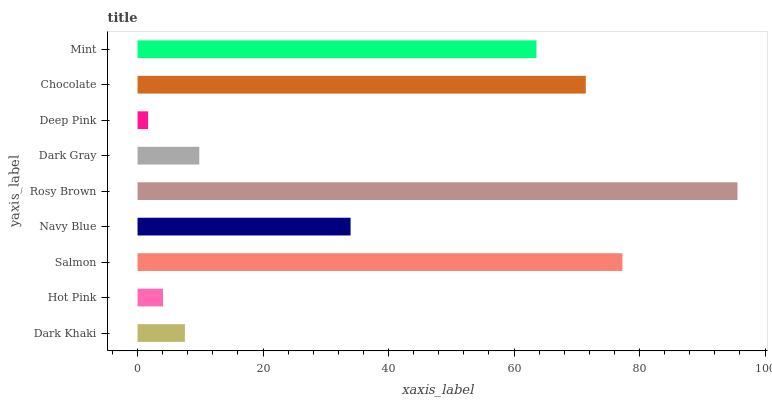Is Deep Pink the minimum?
Answer yes or no. Yes. Is Rosy Brown the maximum?
Answer yes or no. Yes. Is Hot Pink the minimum?
Answer yes or no. No. Is Hot Pink the maximum?
Answer yes or no. No. Is Dark Khaki greater than Hot Pink?
Answer yes or no. Yes. Is Hot Pink less than Dark Khaki?
Answer yes or no. Yes. Is Hot Pink greater than Dark Khaki?
Answer yes or no. No. Is Dark Khaki less than Hot Pink?
Answer yes or no. No. Is Navy Blue the high median?
Answer yes or no. Yes. Is Navy Blue the low median?
Answer yes or no. Yes. Is Deep Pink the high median?
Answer yes or no. No. Is Dark Khaki the low median?
Answer yes or no. No. 